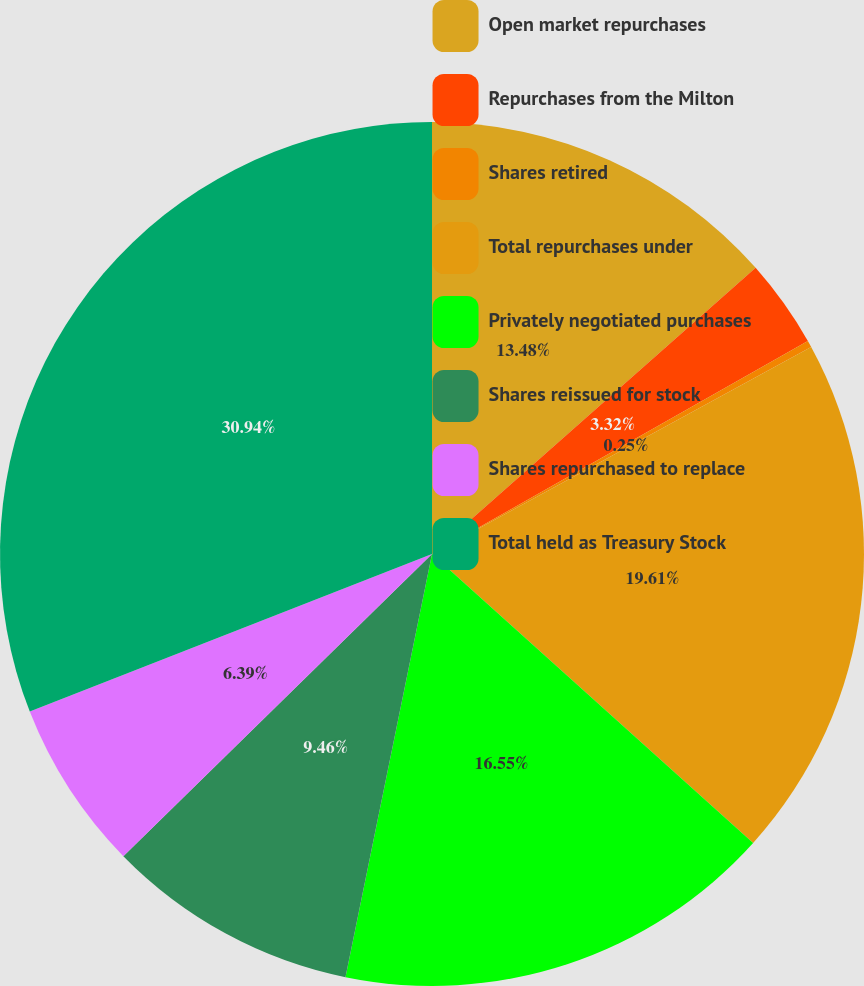Convert chart. <chart><loc_0><loc_0><loc_500><loc_500><pie_chart><fcel>Open market repurchases<fcel>Repurchases from the Milton<fcel>Shares retired<fcel>Total repurchases under<fcel>Privately negotiated purchases<fcel>Shares reissued for stock<fcel>Shares repurchased to replace<fcel>Total held as Treasury Stock<nl><fcel>13.48%<fcel>3.32%<fcel>0.25%<fcel>19.62%<fcel>16.55%<fcel>9.46%<fcel>6.39%<fcel>30.95%<nl></chart> 